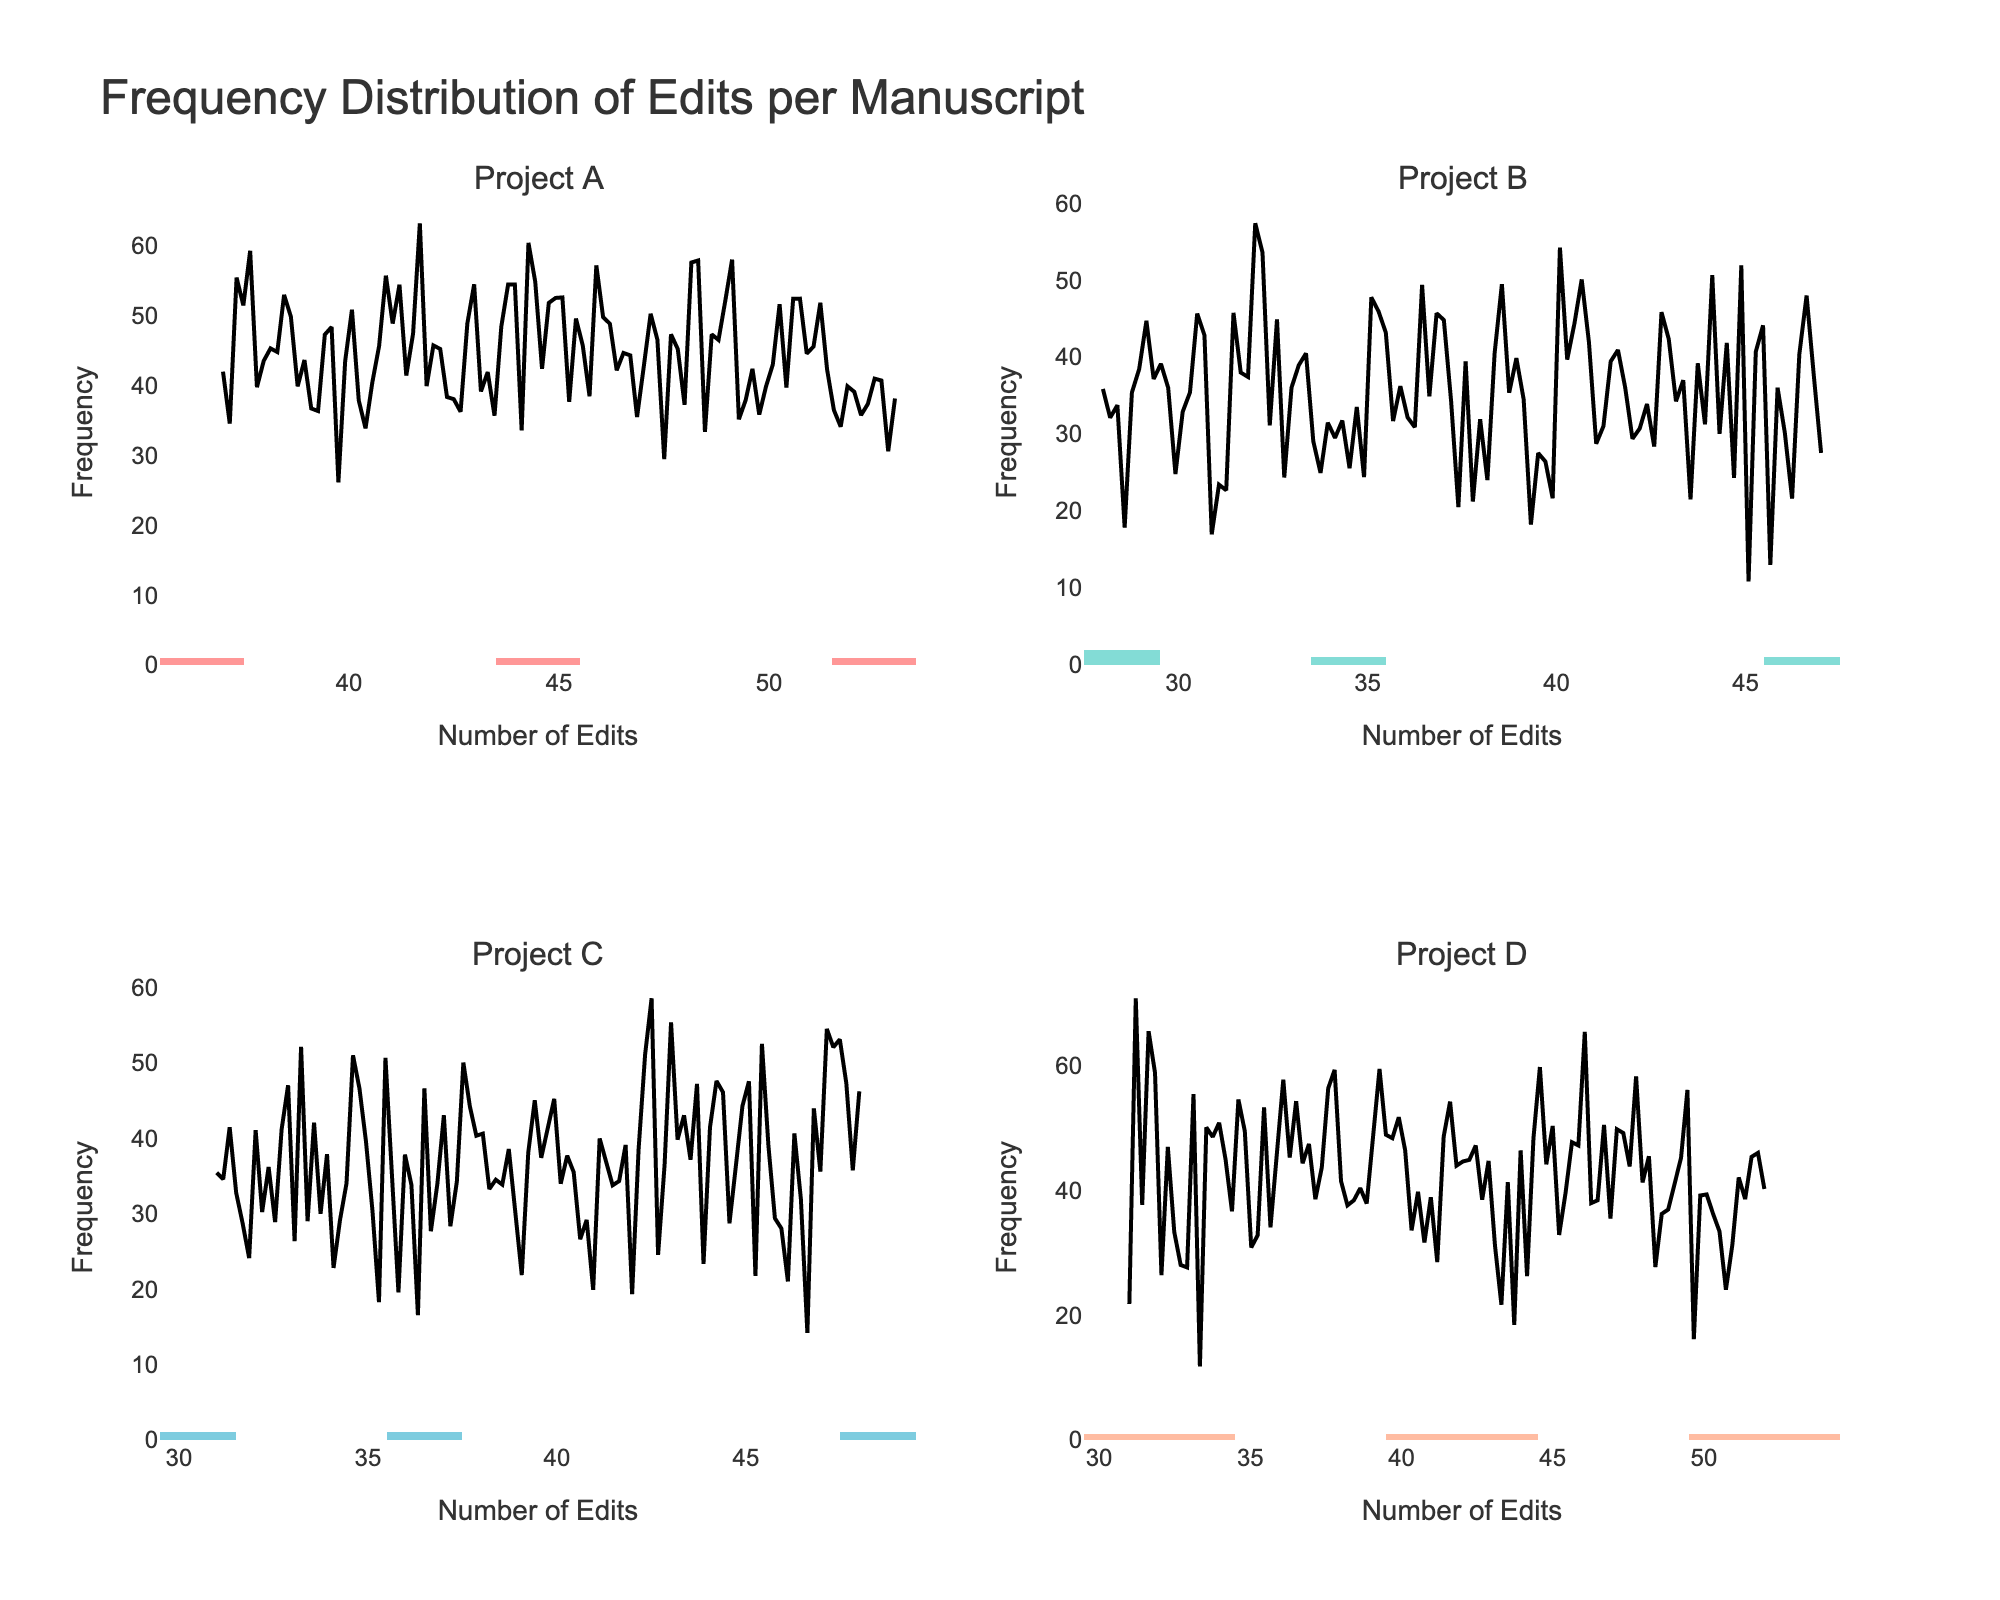What's the title of the chart? You can find the title at the top of the chart. It reads "Frequency Distribution of Edits per Manuscript".
Answer: Frequency Distribution of Edits per Manuscript Which project has the highest number of edits in a single manuscript? By looking at the tallest bar across all histograms, Project A has the highest number of edits in a single manuscript, which is 53.
Answer: Project A What's the range of edits for manuscripts in Project B? The x-axis for Project B shows that the edits range from 28 to 47. This is determined by finding the minimum and maximum values on the histogram for Project B.
Answer: 28 to 47 How does the average of edits compare between Project A and Project C? To find and compare the averages, visually estimate the center of the data distribution for both projects on their respective histograms. Project A has a higher average number of edits than Project C.
Answer: Project A has a higher average Which project appears to be the most consistent in terms of the edit frequency across its manuscripts? Consistency can be inferred from a narrow distribution. Project B has a tighter cluster of bars indicating a smaller spread and thus more consistent frequency.
Answer: Project B Are there any projects where the edits nearly follow a normal distribution? Look for a bell-shaped curve in the KDE plots. Project C’s KDE appears closest to a normal distribution compared to others.
Answer: Project C How many projects have a manuscript with over 50 edits? Check the highest bars' values on each subplot. Projects A, C, and D each have one manuscript with more than 50 edits.
Answer: Three projects Which project has the widest distribution of edits? A wide distribution will have bars spanning a larger range on the x-axis. Project D has a wide range as the bars span from approximately 31 to 52 edits.
Answer: Project D Is there any project where all manuscripts have fewer than 40 edits? Check each subplot to see if any has all bars below 40. None of the projects meet this criterion as all have manuscripts with edits greater than 40.
Answer: No What can be concluded about the number of edits per manuscript in Project C based on its histogram and line plot? Project C’s histogram shows a fairly equal distribution among the different edit counts, with the KDE line indicating that the edits are roughly normally distributed around the mean.
Answer: Fairly equal, roughly normal distribution 